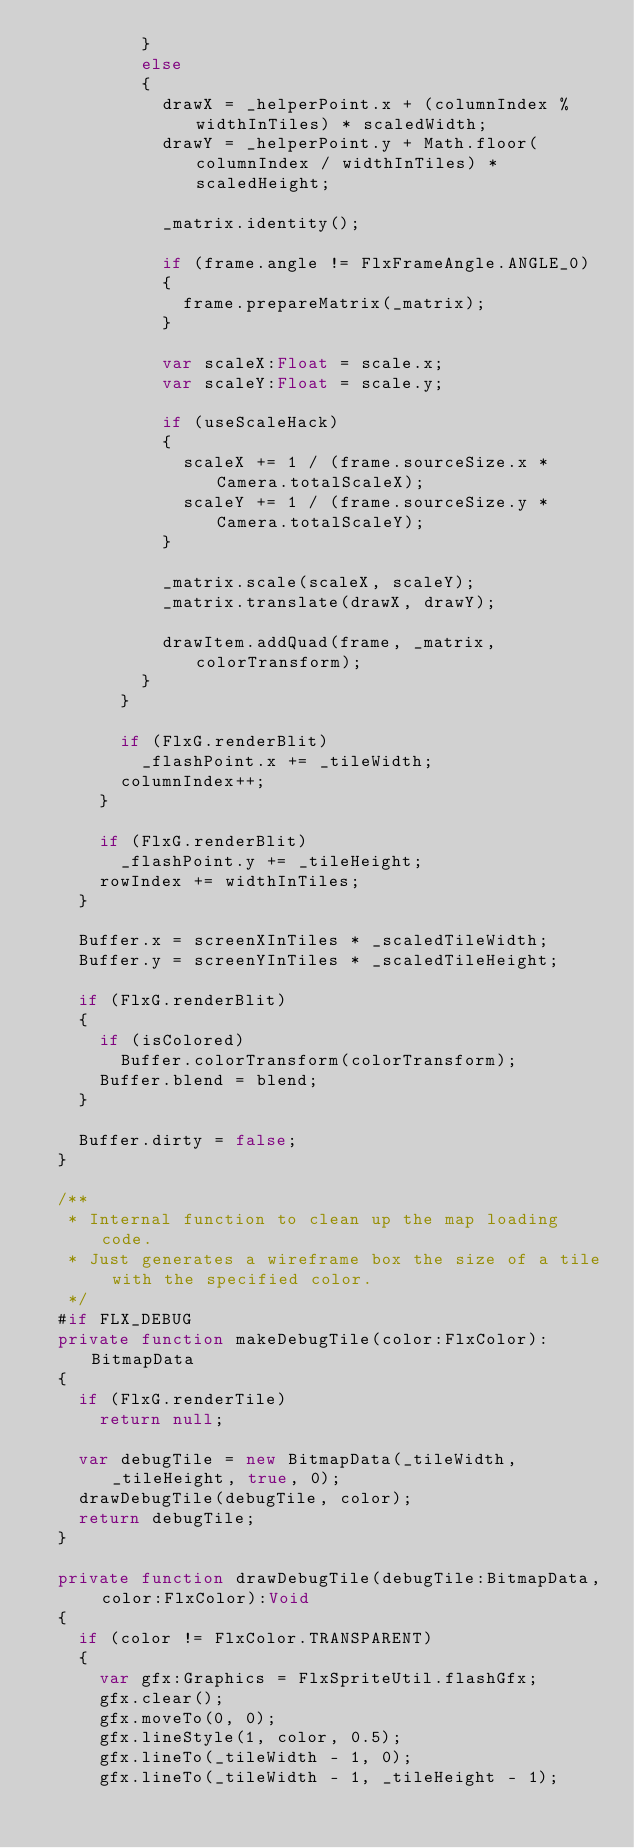Convert code to text. <code><loc_0><loc_0><loc_500><loc_500><_Haxe_>					}
					else
					{
						drawX = _helperPoint.x + (columnIndex % widthInTiles) * scaledWidth;
						drawY = _helperPoint.y + Math.floor(columnIndex / widthInTiles) * scaledHeight;
						
						_matrix.identity();
						
						if (frame.angle != FlxFrameAngle.ANGLE_0)
						{
							frame.prepareMatrix(_matrix);
						}
						
						var scaleX:Float = scale.x;
						var scaleY:Float = scale.y;
						
						if (useScaleHack)
						{
							scaleX += 1 / (frame.sourceSize.x * Camera.totalScaleX);
							scaleY += 1 / (frame.sourceSize.y * Camera.totalScaleY);
						}
						
						_matrix.scale(scaleX, scaleY);
						_matrix.translate(drawX, drawY);
						
						drawItem.addQuad(frame, _matrix, colorTransform);
					}
				}
				
				if (FlxG.renderBlit)
					_flashPoint.x += _tileWidth;
				columnIndex++;
			}
			
			if (FlxG.renderBlit)
				_flashPoint.y += _tileHeight;
			rowIndex += widthInTiles;
		}
		
		Buffer.x = screenXInTiles * _scaledTileWidth;
		Buffer.y = screenYInTiles * _scaledTileHeight;
		
		if (FlxG.renderBlit)
		{
			if (isColored)
				Buffer.colorTransform(colorTransform);
			Buffer.blend = blend;
		}
		
		Buffer.dirty = false;
	}
	
	/**
	 * Internal function to clean up the map loading code.
	 * Just generates a wireframe box the size of a tile with the specified color.
	 */
	#if FLX_DEBUG
	private function makeDebugTile(color:FlxColor):BitmapData
	{
		if (FlxG.renderTile)
			return null;

		var debugTile = new BitmapData(_tileWidth, _tileHeight, true, 0);
		drawDebugTile(debugTile, color);
		return debugTile;
	}
	
	private function drawDebugTile(debugTile:BitmapData, color:FlxColor):Void
	{
		if (color != FlxColor.TRANSPARENT)
		{
			var gfx:Graphics = FlxSpriteUtil.flashGfx;
			gfx.clear();
			gfx.moveTo(0, 0);
			gfx.lineStyle(1, color, 0.5);
			gfx.lineTo(_tileWidth - 1, 0);
			gfx.lineTo(_tileWidth - 1, _tileHeight - 1);</code> 